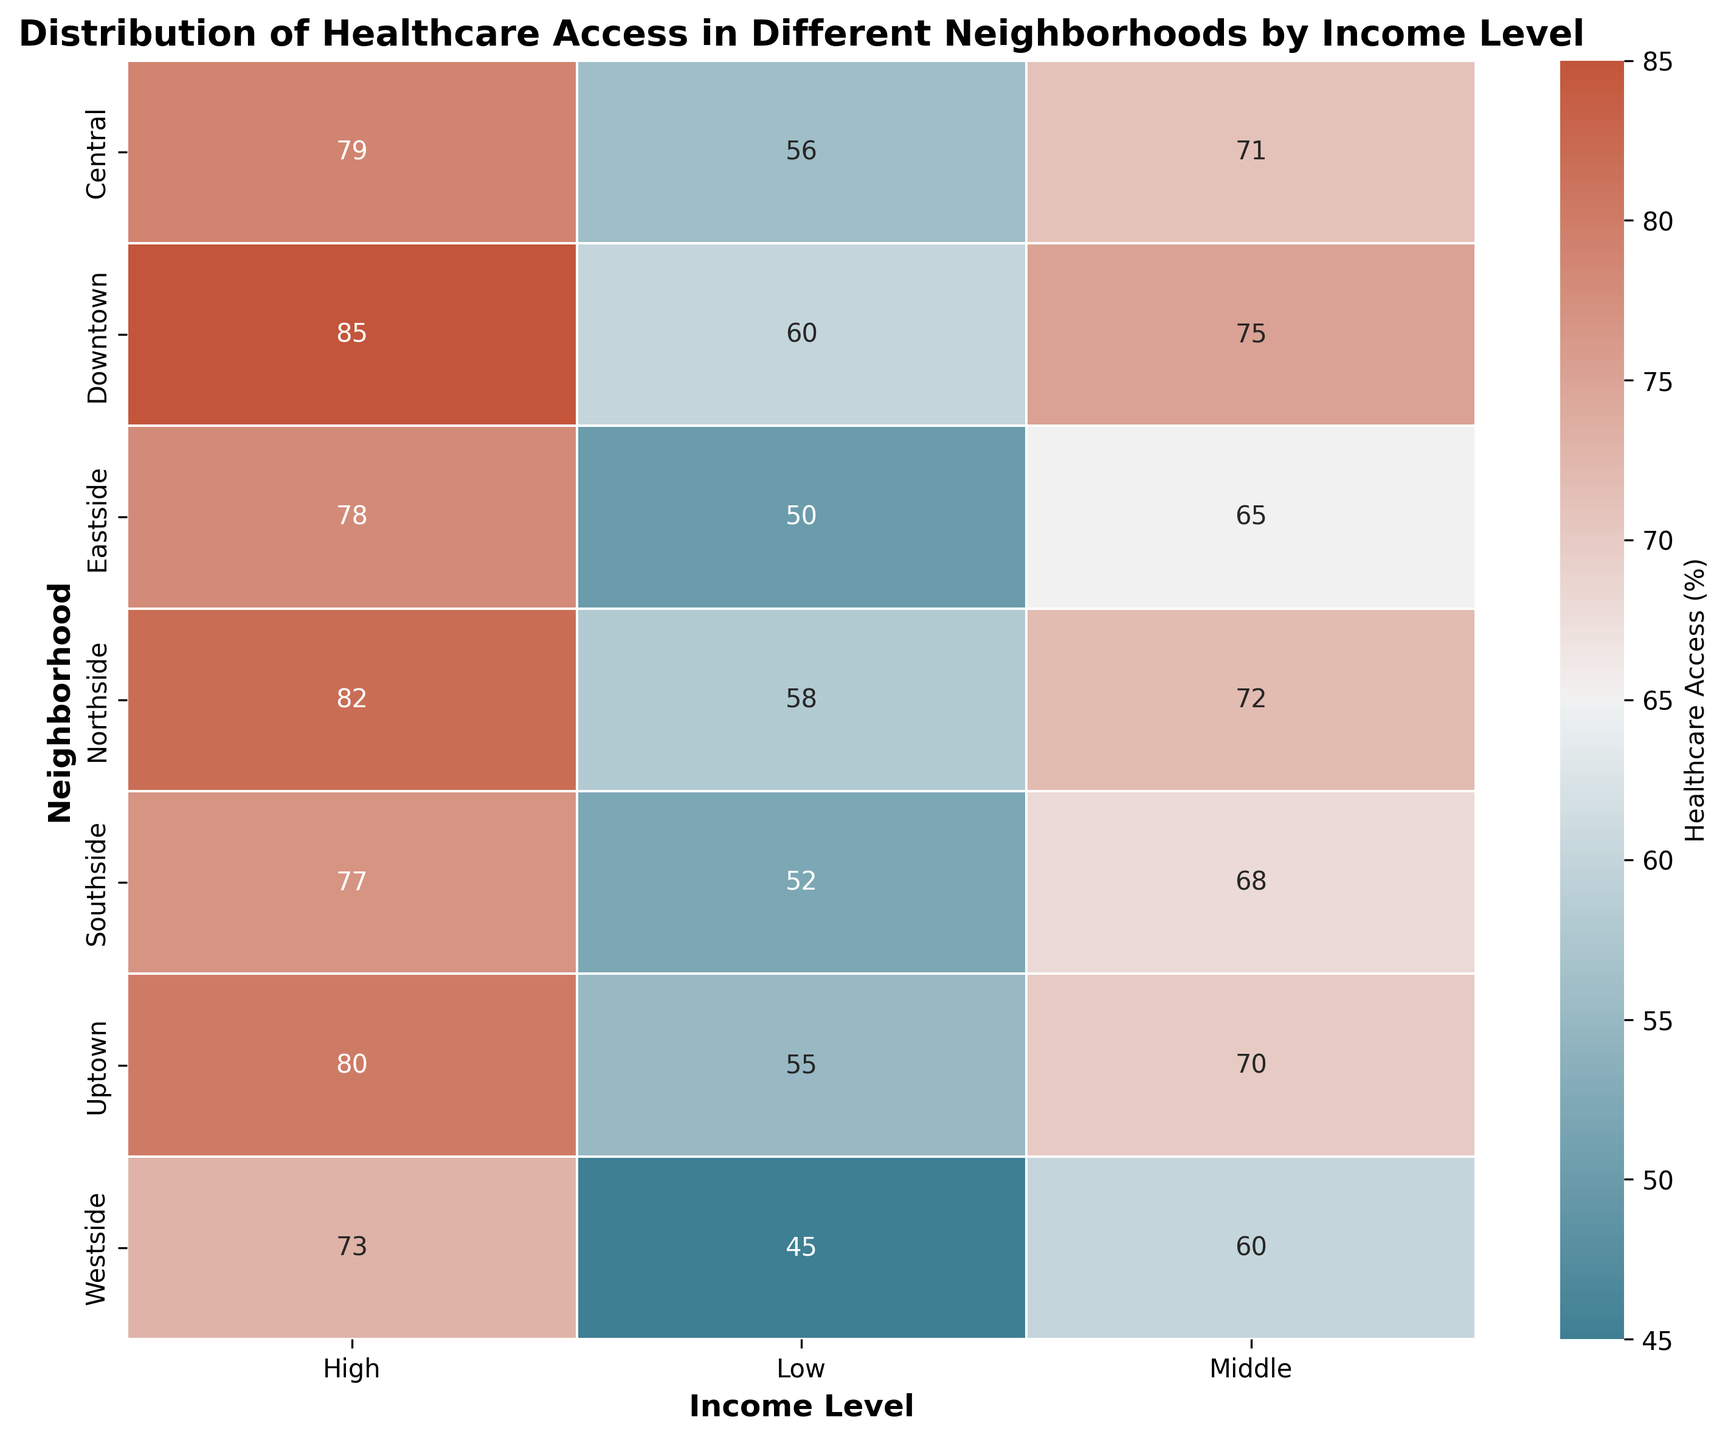What neighborhood has the highest healthcare access for the high income level? Locate the column for the high-income level and identify the highest value. The highest value is 85 in the Downtown neighborhood.
Answer: Downtown Which income level has the lowest healthcare access in Westside? Find the row for Westside and compare the values across different income levels. The lowest value is 45 in the low-income level.
Answer: Low Compare the healthcare access between Eastside and Northside for the middle-income level. Which one is higher? Identify the middle-income level for both neighborhoods. The values are 65 for Eastside and 72 for Northside. Thus, Northside is higher.
Answer: Northside What is the average healthcare access for Uptown? Add the values for Uptown: (55+70+80) and divide by 3. The calculation is (55+70+80)=205, so 205/3=68.33
Answer: 68.33 Which neighborhood has the least variability in healthcare access across different income levels? Look at the differences in the values within each neighborhood's row. Central has values fairly close together: 56, 71, and 79, with a range of 23 (79-56).
Answer: Central Is there any neighborhood where healthcare access decreases with increasing income level? Check all rows to see if any values decrease from low to high income. No neighborhood shows a decreasing trend from low to high income.
Answer: No What is the total healthcare access score for Southside across all income levels? Add the values for Southside: 52 + 68 + 77. The calculation is 52+68+77=197.
Answer: 197 How does the healthcare access for low-income residents in Downtown compare to those in Westside? Compare the values for low-income residents in both neighborhoods. Downtown's value is 60, and Westside's is 45. Thus, Downtown has higher access.
Answer: Downtown Which income bracket shows the most significant difference in healthcare access between Downtown and Eastside? Compare the differences in values for each income bracket between the two neighborhoods. The differences are 10 for low (60-50), 10 for middle (75-65), and 7 for high (85-78). The most significant difference is 10.
Answer: Low and Middle What is the range of healthcare access values in Northside? Find the maximum and minimum values in the Northside row and calculate the difference. The values are 58 (low) and 82 (high), so the range is 82-58=24.
Answer: 24 